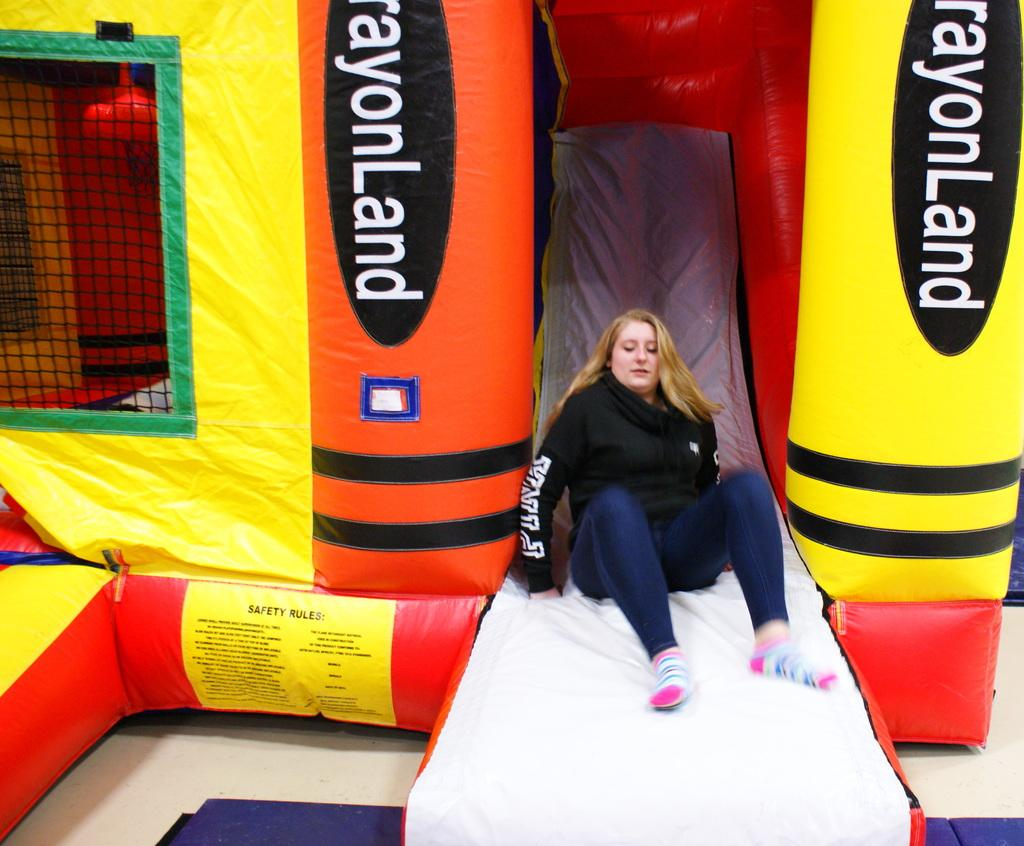Who is the main subject in the image? There is a woman in the image. What is the woman doing in the image? The woman is sliding over an air balloon. What is the woman wearing in the image? The woman is wearing a black color sweater. What type of structure is present in the image? There is an air balloon house in the image. Can you see any lakes or bodies of water in the image? There is no lake or body of water visible in the image. Is there a seat or chair for the woman to sit on in the image? The woman is sliding over an air balloon, and there is no seat or chair present in the image. 